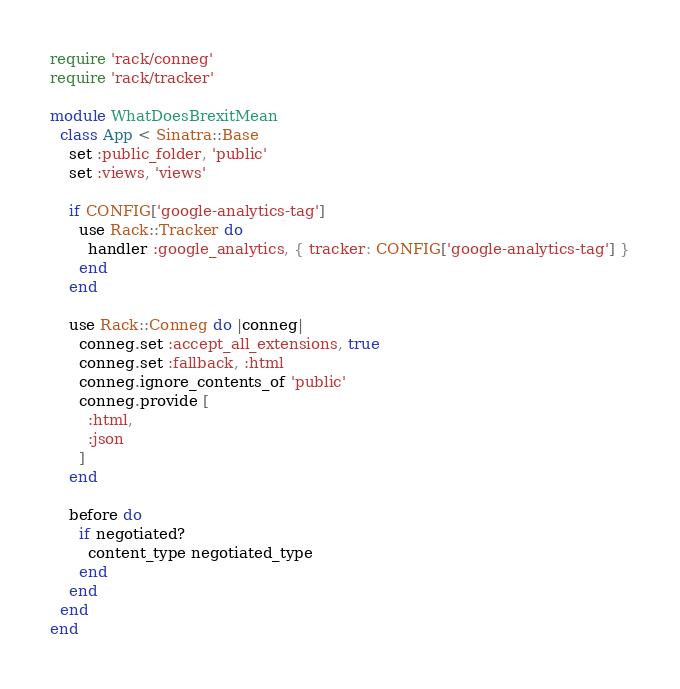<code> <loc_0><loc_0><loc_500><loc_500><_Ruby_>require 'rack/conneg'
require 'rack/tracker'

module WhatDoesBrexitMean
  class App < Sinatra::Base
    set :public_folder, 'public'
    set :views, 'views'

    if CONFIG['google-analytics-tag']
      use Rack::Tracker do
        handler :google_analytics, { tracker: CONFIG['google-analytics-tag'] }
      end
    end

    use Rack::Conneg do |conneg|
      conneg.set :accept_all_extensions, true
      conneg.set :fallback, :html
      conneg.ignore_contents_of 'public'
      conneg.provide [
        :html,
        :json
      ]
    end

    before do
      if negotiated?
        content_type negotiated_type
      end
    end
  end
end
</code> 